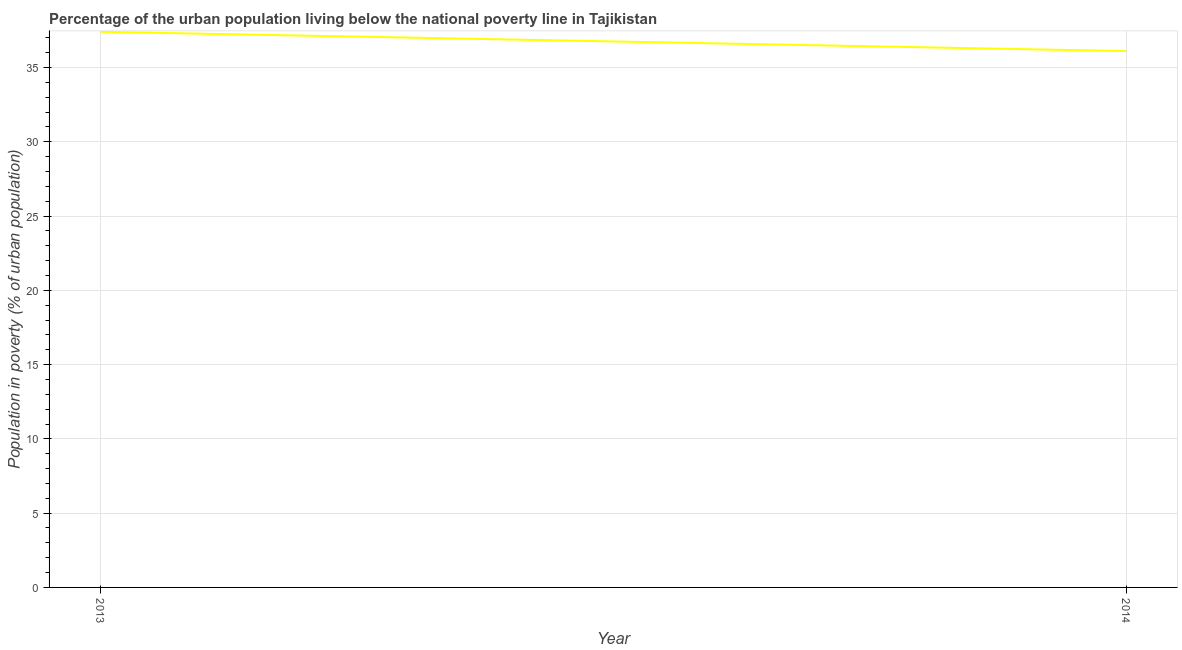What is the percentage of urban population living below poverty line in 2013?
Offer a very short reply. 37.4. Across all years, what is the maximum percentage of urban population living below poverty line?
Offer a very short reply. 37.4. Across all years, what is the minimum percentage of urban population living below poverty line?
Your response must be concise. 36.1. In which year was the percentage of urban population living below poverty line maximum?
Offer a terse response. 2013. In which year was the percentage of urban population living below poverty line minimum?
Provide a short and direct response. 2014. What is the sum of the percentage of urban population living below poverty line?
Offer a very short reply. 73.5. What is the difference between the percentage of urban population living below poverty line in 2013 and 2014?
Provide a short and direct response. 1.3. What is the average percentage of urban population living below poverty line per year?
Your answer should be compact. 36.75. What is the median percentage of urban population living below poverty line?
Ensure brevity in your answer.  36.75. Do a majority of the years between 2013 and 2014 (inclusive) have percentage of urban population living below poverty line greater than 23 %?
Your answer should be compact. Yes. What is the ratio of the percentage of urban population living below poverty line in 2013 to that in 2014?
Ensure brevity in your answer.  1.04. Is the percentage of urban population living below poverty line in 2013 less than that in 2014?
Keep it short and to the point. No. In how many years, is the percentage of urban population living below poverty line greater than the average percentage of urban population living below poverty line taken over all years?
Provide a short and direct response. 1. Does the percentage of urban population living below poverty line monotonically increase over the years?
Keep it short and to the point. No. What is the title of the graph?
Provide a succinct answer. Percentage of the urban population living below the national poverty line in Tajikistan. What is the label or title of the Y-axis?
Make the answer very short. Population in poverty (% of urban population). What is the Population in poverty (% of urban population) of 2013?
Your answer should be very brief. 37.4. What is the Population in poverty (% of urban population) in 2014?
Offer a terse response. 36.1. What is the difference between the Population in poverty (% of urban population) in 2013 and 2014?
Ensure brevity in your answer.  1.3. What is the ratio of the Population in poverty (% of urban population) in 2013 to that in 2014?
Offer a very short reply. 1.04. 